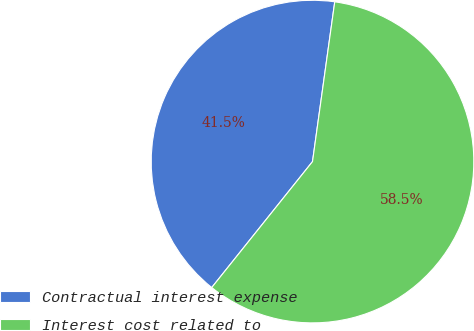Convert chart to OTSL. <chart><loc_0><loc_0><loc_500><loc_500><pie_chart><fcel>Contractual interest expense<fcel>Interest cost related to<nl><fcel>41.46%<fcel>58.54%<nl></chart> 